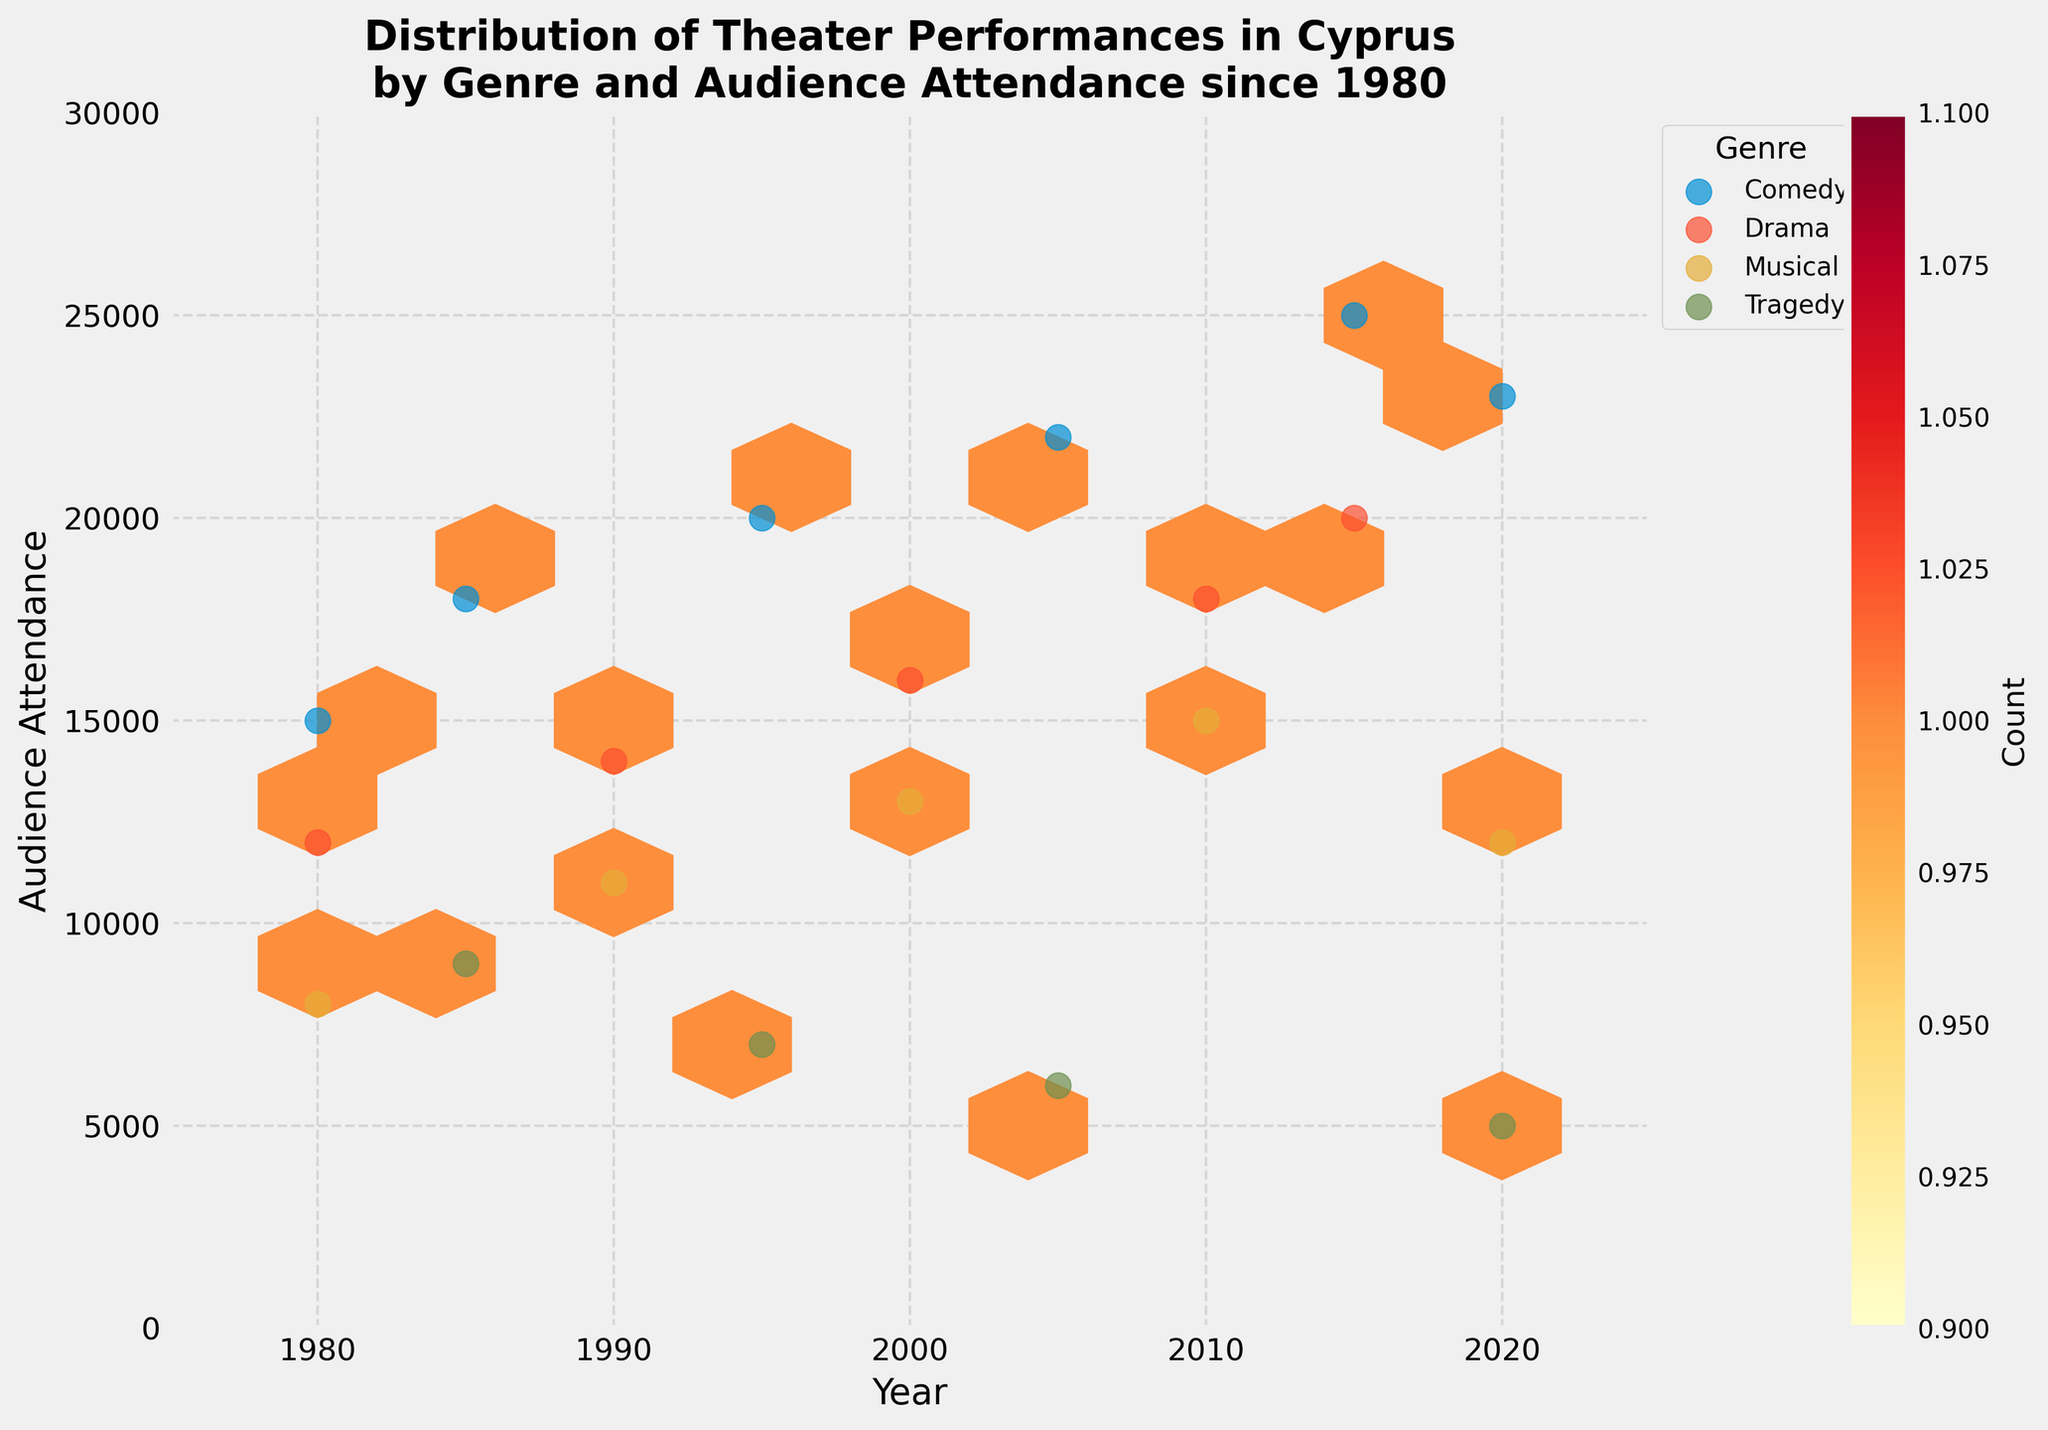How many genres are represented in the plot? Count the unique genres represented by the different markers (e.g., Comedy, Drama, Musical, Tragedy).
Answer: 4 Which genre seems to have the highest audience attendance in the latest year shown? Look at the data points in the most recent year (2020) and identify the genre with the highest y-value (Audience Attendance).
Answer: Comedy What is the average attendance for Drama performances over the displayed years? Identify all data points for Drama, sum their y-values, and then divide by the number of Drama data points. For Drama, y-values are 12000, 14000, 16000, 18000, 20000. Average = (12000 + 14000 + 16000 + 18000 + 20000) / 5 = 16000.
Answer: 16000 During which range of years is there a notable increase in audience attendance for Comedy? Observe the distribution of the Comedy data points along the x-axis (Year), and identify any noticeable upward trend in y-values (Audience Attendance). Increment is notably seen from 1980 to 2020.
Answer: 1980 to 2020 Which year has the least number of data points across all genres? Look at the x-axis and identify the year with the fewest total data points (markings). The fewest are present in 1985 and 1995.
Answer: 1985 and 1995 Which genre has the greatest variability in audience attendance over the years? Identify the genre whose data points show the widest range (difference between the highest and lowest y-values). Comedy's audience attendance ranges from 15000 to 25000, the widest among genres.
Answer: Comedy Is there any overlap in audience attendance ranges between Drama and Musical performances? Observe the y-values for Drama and Musical; determine if their ranges intersect. Drama ranges from 12000 to 20000, Musical from 8000 to 15000, therefore, overlap is 12000-15000.
Answer: Yes How does the audience attendance for Tragedy performances in 2020 compare to that in 1985? Identify the y-values for Tragedy in 2020 (5000) and 1985 (9000); compare these values.
Answer: 2020 has less attendance than 1985 What is the overall trend in audience attendance for Musical performances from 1980 to 2020? Observe the Musical data points and their progression along the x-axis in terms of y-values, assessing whether there is an upward, downward, or irregular trend. Musical starts from 8000 in 1980 and ends at 12000 in 2020 with some fluctuations.
Answer: Upward trend overall 